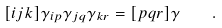Convert formula to latex. <formula><loc_0><loc_0><loc_500><loc_500>[ i j k ] \gamma _ { i p } \gamma _ { j q } \gamma _ { k r } = [ p q r ] \gamma \quad .</formula> 